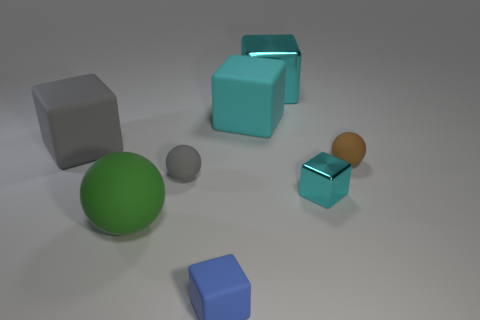Is the small gray rubber thing the same shape as the tiny cyan metal thing?
Your answer should be very brief. No. Does the tiny metallic cube have the same color as the large rubber cube that is to the left of the small blue block?
Offer a terse response. No. How many things are either big rubber things that are behind the green sphere or big blocks behind the gray rubber block?
Keep it short and to the point. 3. Are there more tiny rubber spheres that are in front of the blue matte cube than big balls right of the green sphere?
Keep it short and to the point. No. What is the tiny block that is left of the large cyan cube that is behind the rubber cube that is to the right of the blue object made of?
Your response must be concise. Rubber. There is a small thing behind the gray rubber ball; is it the same shape as the big matte object that is behind the large gray cube?
Offer a terse response. No. Are there any gray metallic things that have the same size as the cyan rubber thing?
Offer a very short reply. No. How many purple objects are either matte blocks or large rubber objects?
Make the answer very short. 0. How many large balls are the same color as the small metallic object?
Make the answer very short. 0. Are there any other things that have the same shape as the cyan rubber thing?
Your answer should be compact. Yes. 